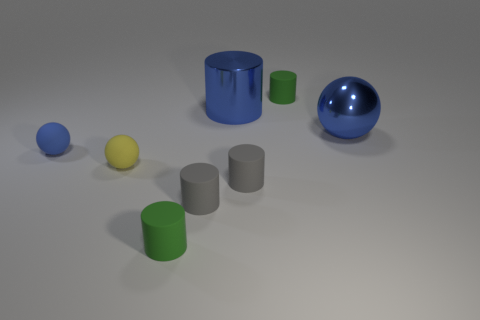Subtract all cyan cylinders. Subtract all purple blocks. How many cylinders are left? 5 Add 1 tiny gray matte cylinders. How many objects exist? 9 Subtract all spheres. How many objects are left? 5 Subtract all tiny yellow rubber objects. Subtract all blue metal objects. How many objects are left? 5 Add 7 gray rubber cylinders. How many gray rubber cylinders are left? 9 Add 8 yellow matte balls. How many yellow matte balls exist? 9 Subtract 0 cyan cylinders. How many objects are left? 8 